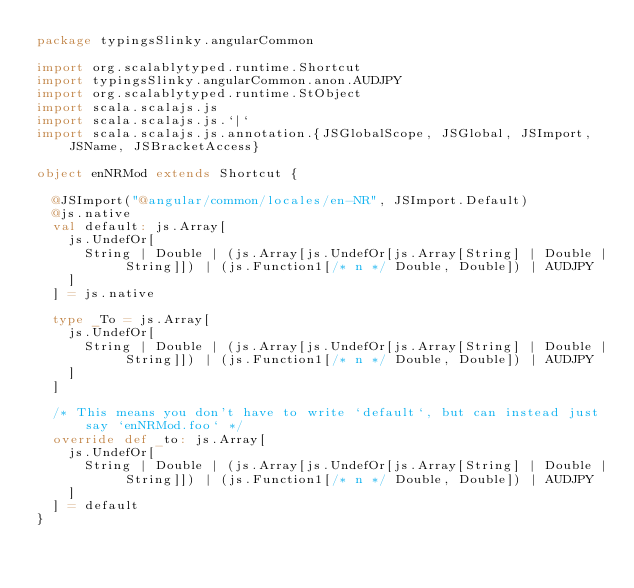<code> <loc_0><loc_0><loc_500><loc_500><_Scala_>package typingsSlinky.angularCommon

import org.scalablytyped.runtime.Shortcut
import typingsSlinky.angularCommon.anon.AUDJPY
import org.scalablytyped.runtime.StObject
import scala.scalajs.js
import scala.scalajs.js.`|`
import scala.scalajs.js.annotation.{JSGlobalScope, JSGlobal, JSImport, JSName, JSBracketAccess}

object enNRMod extends Shortcut {
  
  @JSImport("@angular/common/locales/en-NR", JSImport.Default)
  @js.native
  val default: js.Array[
    js.UndefOr[
      String | Double | (js.Array[js.UndefOr[js.Array[String] | Double | String]]) | (js.Function1[/* n */ Double, Double]) | AUDJPY
    ]
  ] = js.native
  
  type _To = js.Array[
    js.UndefOr[
      String | Double | (js.Array[js.UndefOr[js.Array[String] | Double | String]]) | (js.Function1[/* n */ Double, Double]) | AUDJPY
    ]
  ]
  
  /* This means you don't have to write `default`, but can instead just say `enNRMod.foo` */
  override def _to: js.Array[
    js.UndefOr[
      String | Double | (js.Array[js.UndefOr[js.Array[String] | Double | String]]) | (js.Function1[/* n */ Double, Double]) | AUDJPY
    ]
  ] = default
}
</code> 